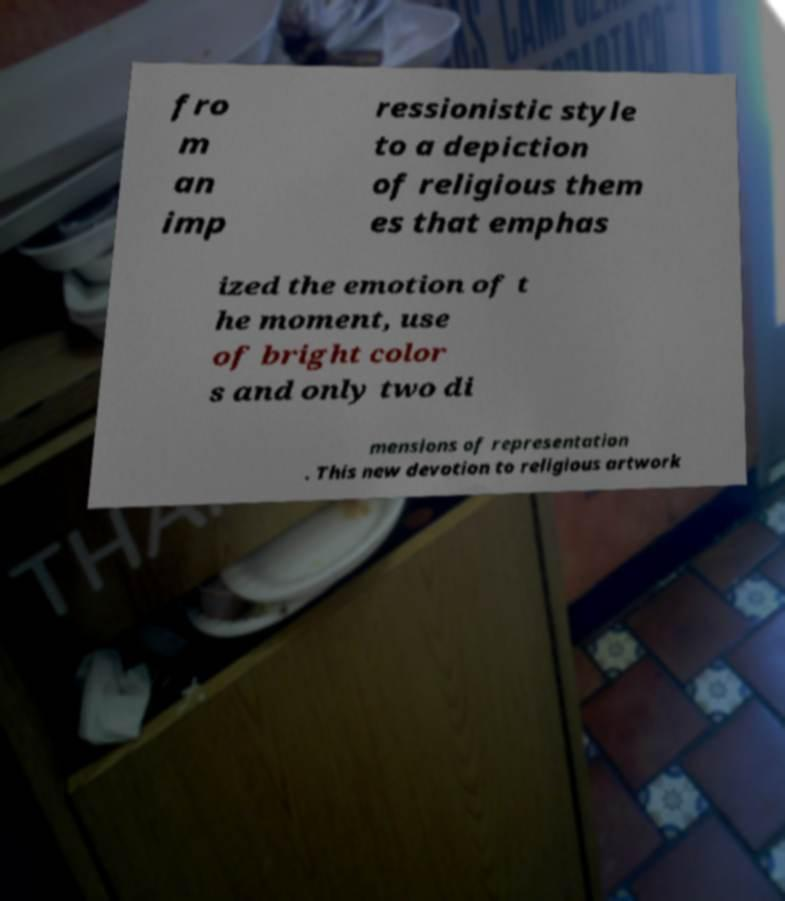I need the written content from this picture converted into text. Can you do that? fro m an imp ressionistic style to a depiction of religious them es that emphas ized the emotion of t he moment, use of bright color s and only two di mensions of representation . This new devotion to religious artwork 